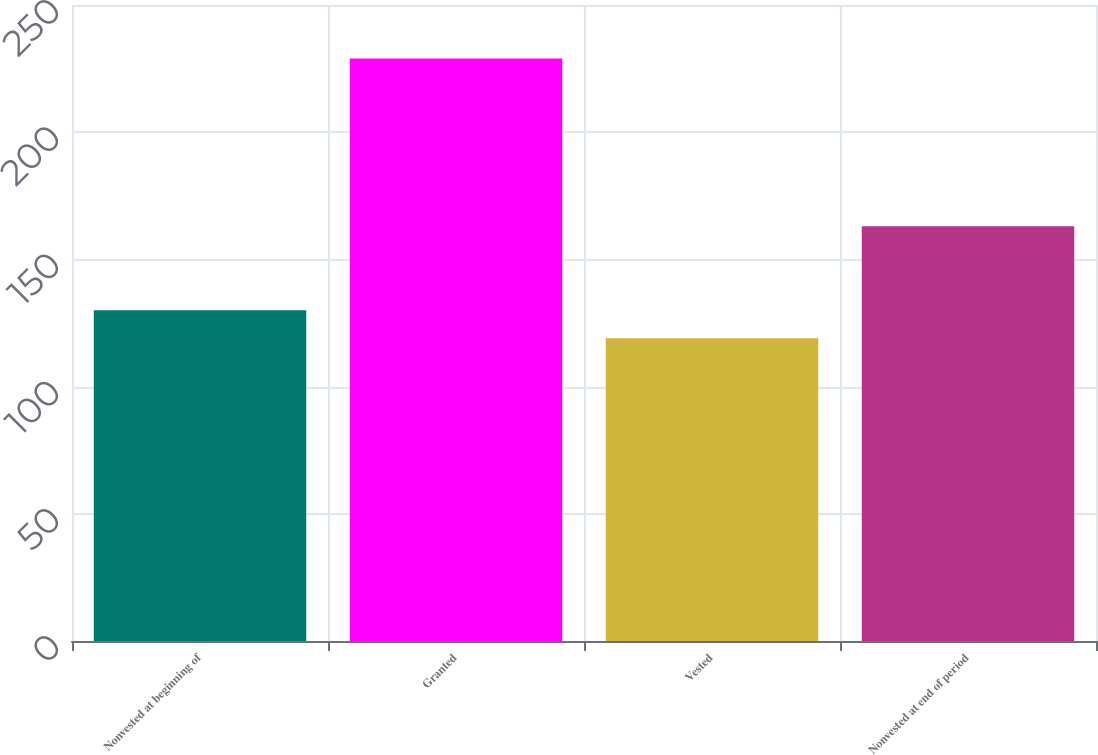Convert chart to OTSL. <chart><loc_0><loc_0><loc_500><loc_500><bar_chart><fcel>Nonvested at beginning of<fcel>Granted<fcel>Vested<fcel>Nonvested at end of period<nl><fcel>130<fcel>229<fcel>119<fcel>163<nl></chart> 